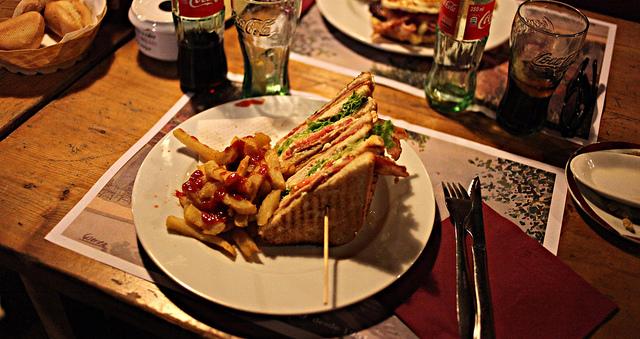What sandwich is it?
Keep it brief. Club. What type of material does the table appear to be made from?
Be succinct. Wood. What is holding this sandwich together?
Keep it brief. Toothpick. 